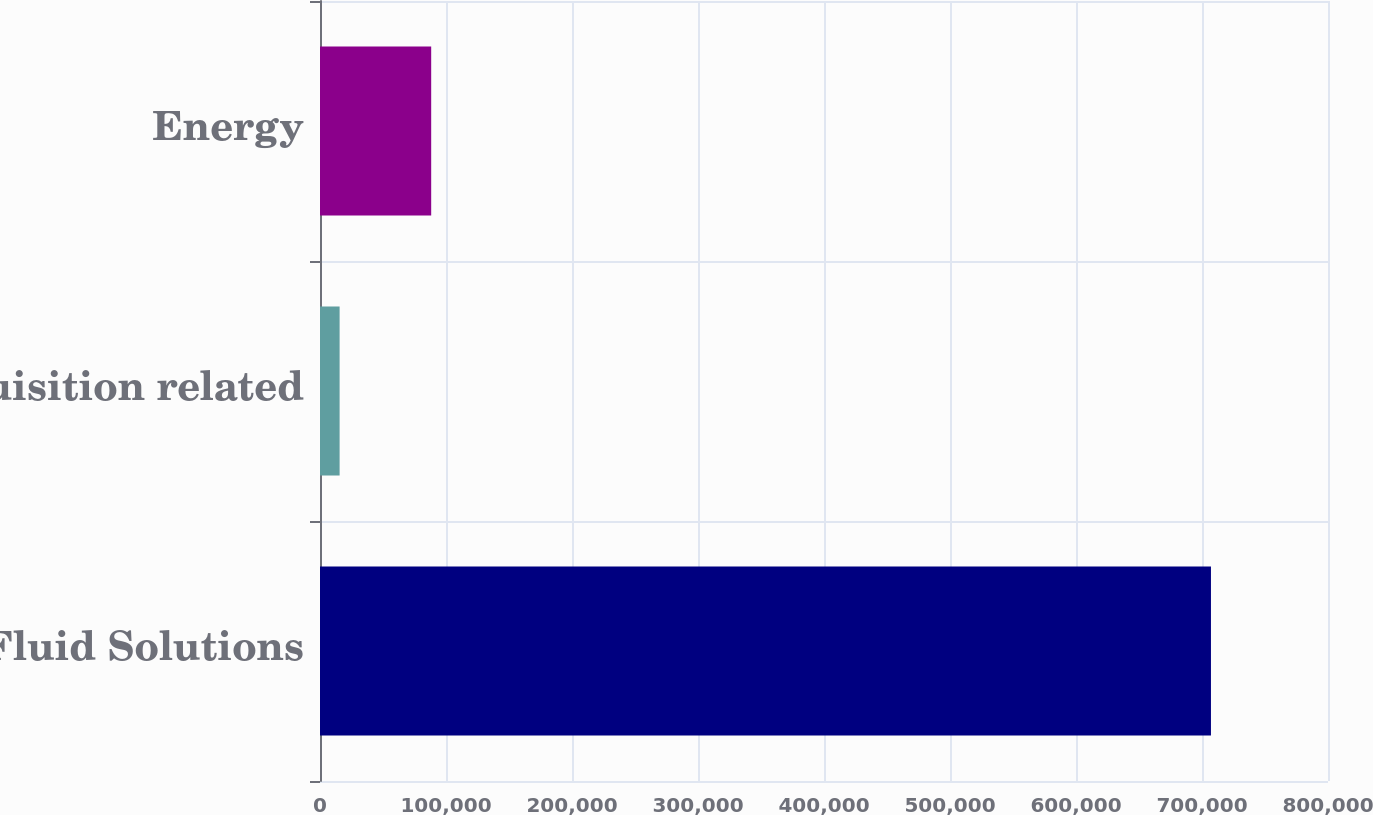<chart> <loc_0><loc_0><loc_500><loc_500><bar_chart><fcel>Fluid Solutions<fcel>Acquisition related<fcel>Energy<nl><fcel>707113<fcel>15569<fcel>88245<nl></chart> 